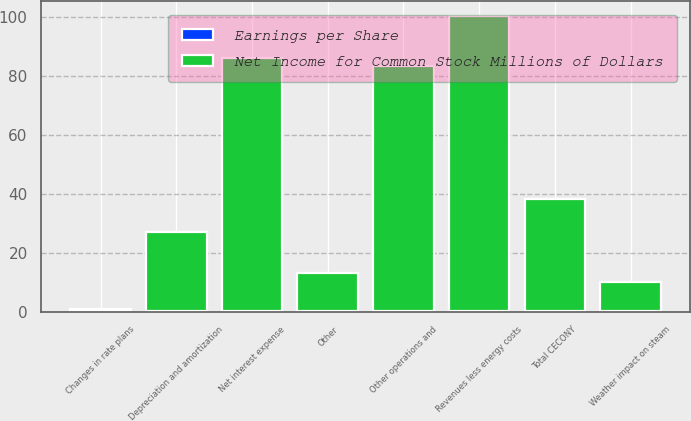Convert chart. <chart><loc_0><loc_0><loc_500><loc_500><stacked_bar_chart><ecel><fcel>Changes in rate plans<fcel>Weather impact on steam<fcel>Other operations and<fcel>Depreciation and amortization<fcel>Other<fcel>Total CECONY<fcel>Revenues less energy costs<fcel>Net interest expense<nl><fcel>Earnings per Share<fcel>0.43<fcel>0.03<fcel>0.28<fcel>0.09<fcel>0.04<fcel>0.13<fcel>0.34<fcel>0.29<nl><fcel>Net Income for Common Stock Millions of Dollars<fcel>0.43<fcel>10<fcel>83<fcel>27<fcel>13<fcel>38<fcel>100<fcel>86<nl></chart> 